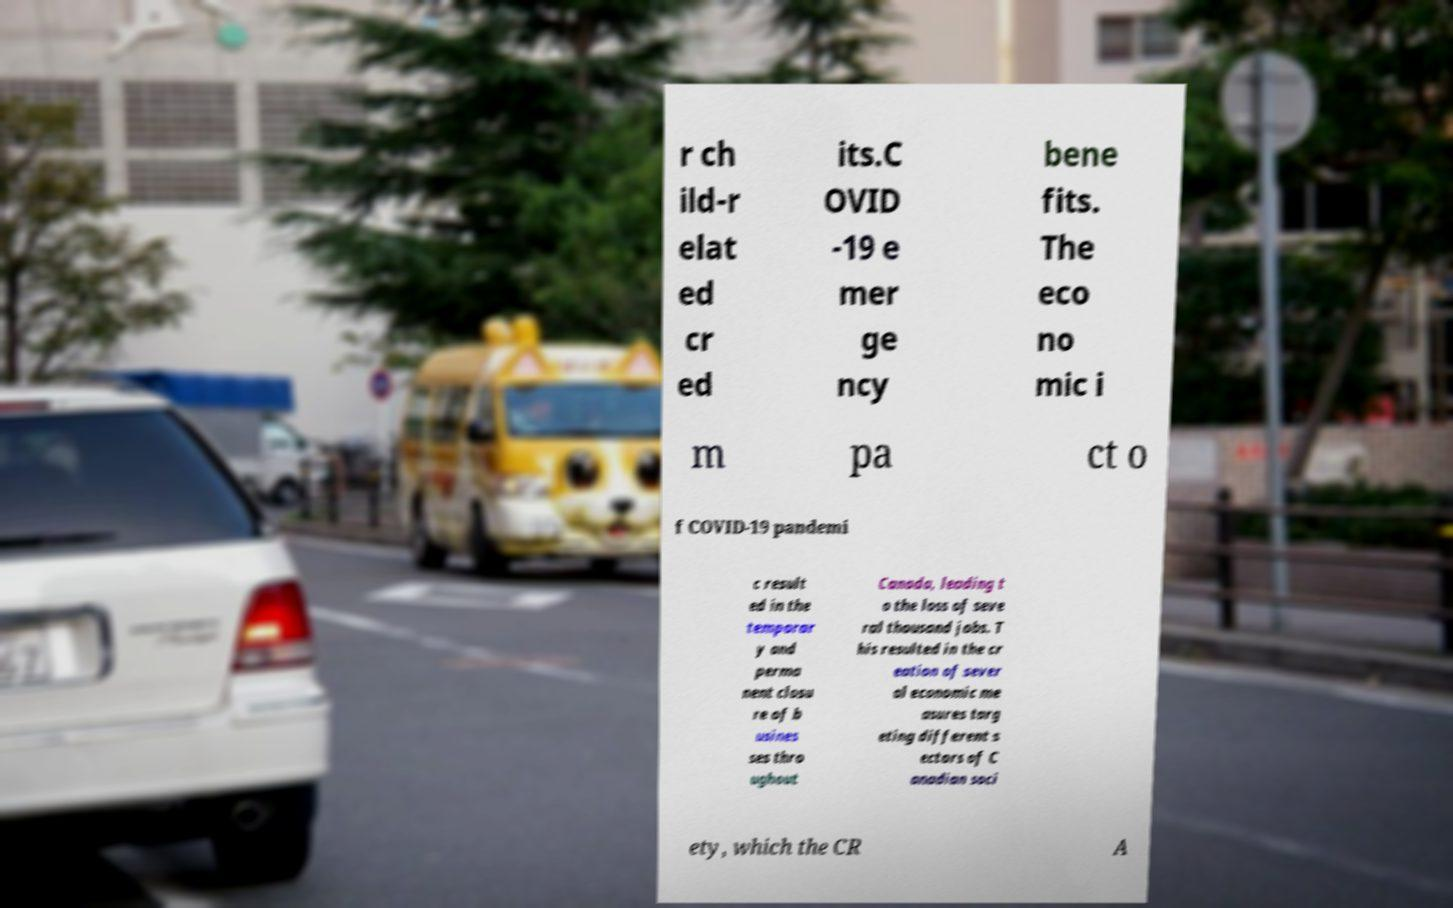Please read and relay the text visible in this image. What does it say? r ch ild-r elat ed cr ed its.C OVID -19 e mer ge ncy bene fits. The eco no mic i m pa ct o f COVID-19 pandemi c result ed in the temporar y and perma nent closu re of b usines ses thro ughout Canada, leading t o the loss of seve ral thousand jobs. T his resulted in the cr eation of sever al economic me asures targ eting different s ectors of C anadian soci ety, which the CR A 